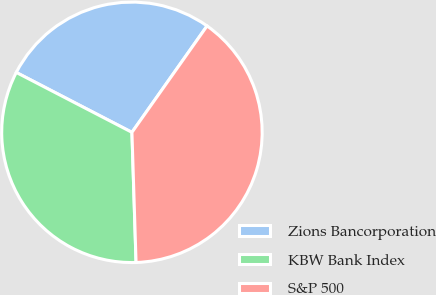Convert chart. <chart><loc_0><loc_0><loc_500><loc_500><pie_chart><fcel>Zions Bancorporation<fcel>KBW Bank Index<fcel>S&P 500<nl><fcel>27.18%<fcel>33.11%<fcel>39.71%<nl></chart> 